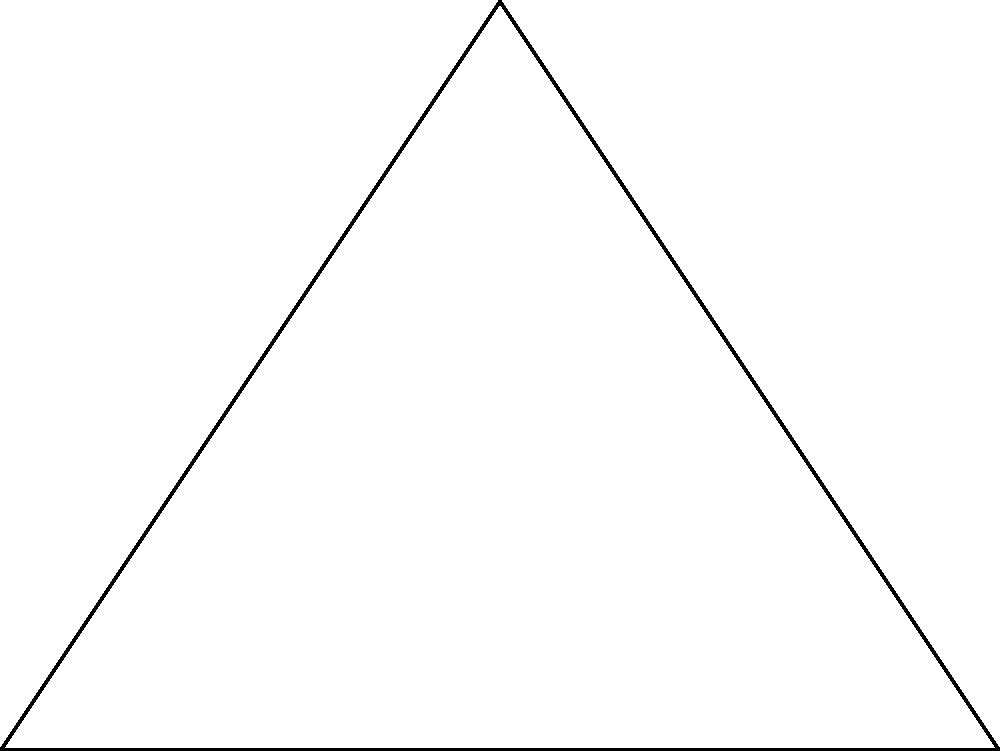In a triangular club layout, you need to position a central speaker to provide equal sound coverage to all corners. If the club's dimensions are represented by triangle ABC with side lengths AB = 4m, BC = 3.6m, and AC = 3.6m, what is the radius (r) of the circle representing the speaker's coverage area? To solve this problem, we'll use the concept of the circumcenter of a triangle, which is equidistant from all vertices.

Step 1: Identify that the speaker should be placed at the circumcenter of the triangle.

Step 2: Calculate the semi-perimeter (s) of the triangle:
$s = \frac{a + b + c}{2} = \frac{4 + 3.6 + 3.6}{2} = 5.6$ m

Step 3: Calculate the area (A) of the triangle using Heron's formula:
$A = \sqrt{s(s-a)(s-b)(s-c)}$
$A = \sqrt{5.6(5.6-4)(5.6-3.6)(5.6-3.6)} = 5.4$ sq m

Step 4: Calculate the radius (r) of the circumcircle using the formula:
$r = \frac{abc}{4A}$

Step 5: Substitute the values:
$r = \frac{4 \times 3.6 \times 3.6}{4 \times 5.4} = 2.4$ m

Therefore, the radius of the circle representing the speaker's coverage area is 2.4 meters.
Answer: 2.4 m 